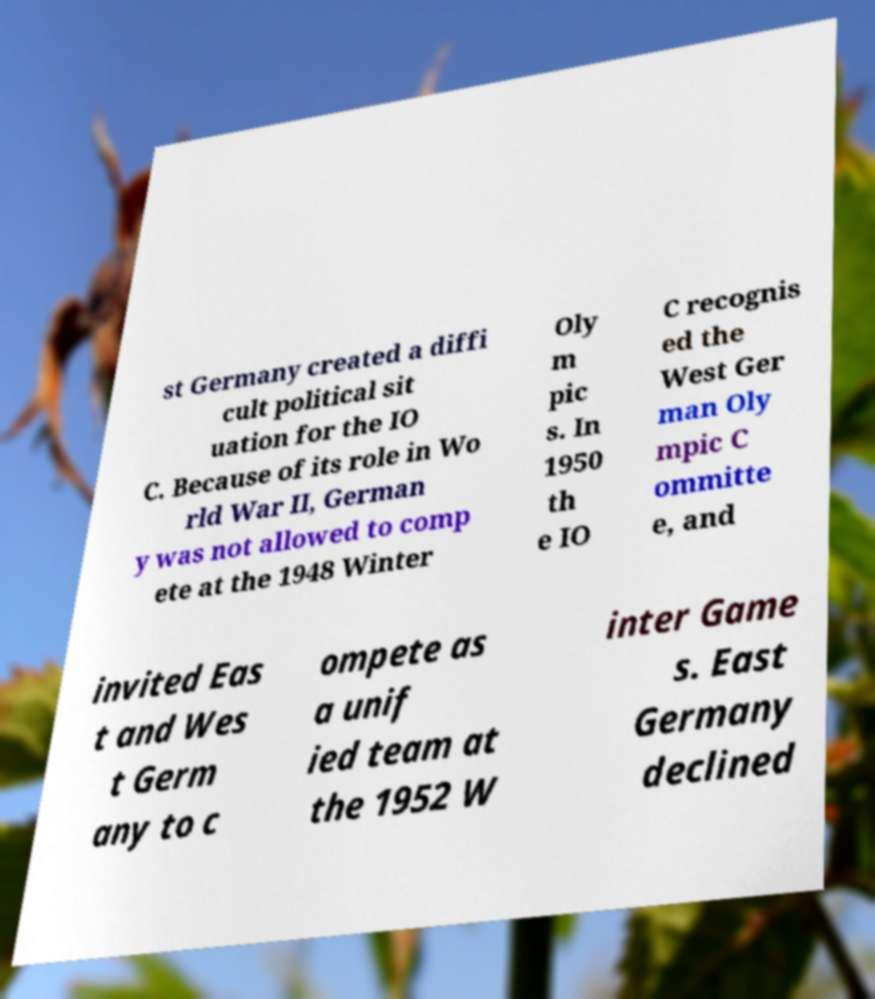There's text embedded in this image that I need extracted. Can you transcribe it verbatim? st Germany created a diffi cult political sit uation for the IO C. Because of its role in Wo rld War II, German y was not allowed to comp ete at the 1948 Winter Oly m pic s. In 1950 th e IO C recognis ed the West Ger man Oly mpic C ommitte e, and invited Eas t and Wes t Germ any to c ompete as a unif ied team at the 1952 W inter Game s. East Germany declined 